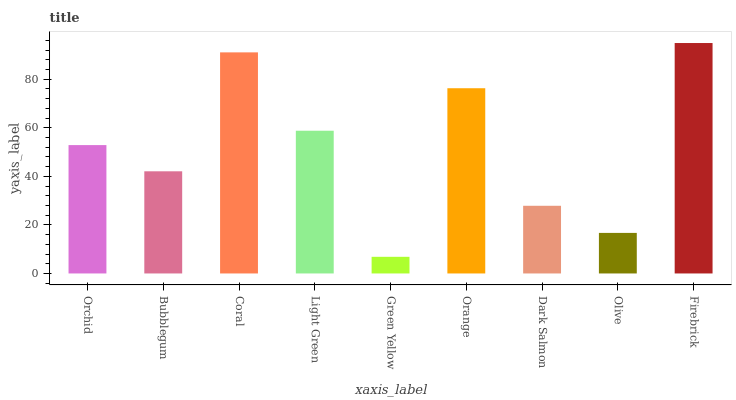Is Green Yellow the minimum?
Answer yes or no. Yes. Is Firebrick the maximum?
Answer yes or no. Yes. Is Bubblegum the minimum?
Answer yes or no. No. Is Bubblegum the maximum?
Answer yes or no. No. Is Orchid greater than Bubblegum?
Answer yes or no. Yes. Is Bubblegum less than Orchid?
Answer yes or no. Yes. Is Bubblegum greater than Orchid?
Answer yes or no. No. Is Orchid less than Bubblegum?
Answer yes or no. No. Is Orchid the high median?
Answer yes or no. Yes. Is Orchid the low median?
Answer yes or no. Yes. Is Orange the high median?
Answer yes or no. No. Is Firebrick the low median?
Answer yes or no. No. 